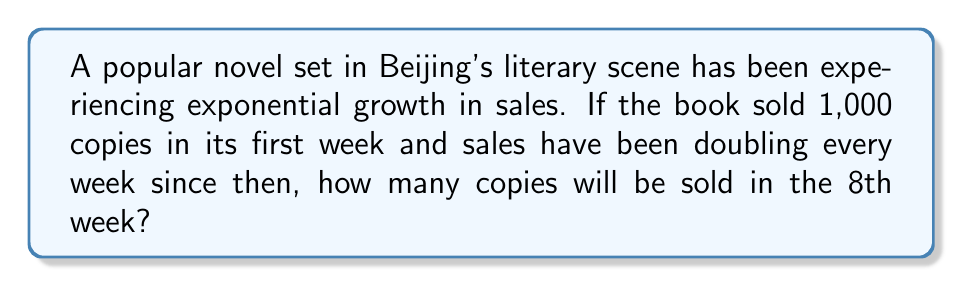Teach me how to tackle this problem. Let's approach this step-by-step:

1) We start with the initial sales of 1,000 copies in the first week.

2) The sales are doubling every week, which means we're multiplying by 2 each time.

3) To find the sales in the 8th week, we need to double the initial amount 7 times (because the first week is our starting point).

4) This can be expressed as an exponential equation:
   $$ \text{Sales in 8th week} = 1000 \times 2^7 $$

5) Now, let's calculate $2^7$:
   $$ 2^7 = 2 \times 2 \times 2 \times 2 \times 2 \times 2 \times 2 = 128 $$

6) So our equation becomes:
   $$ \text{Sales in 8th week} = 1000 \times 128 = 128,000 $$

Therefore, in the 8th week, 128,000 copies of the book will be sold.
Answer: 128,000 copies 